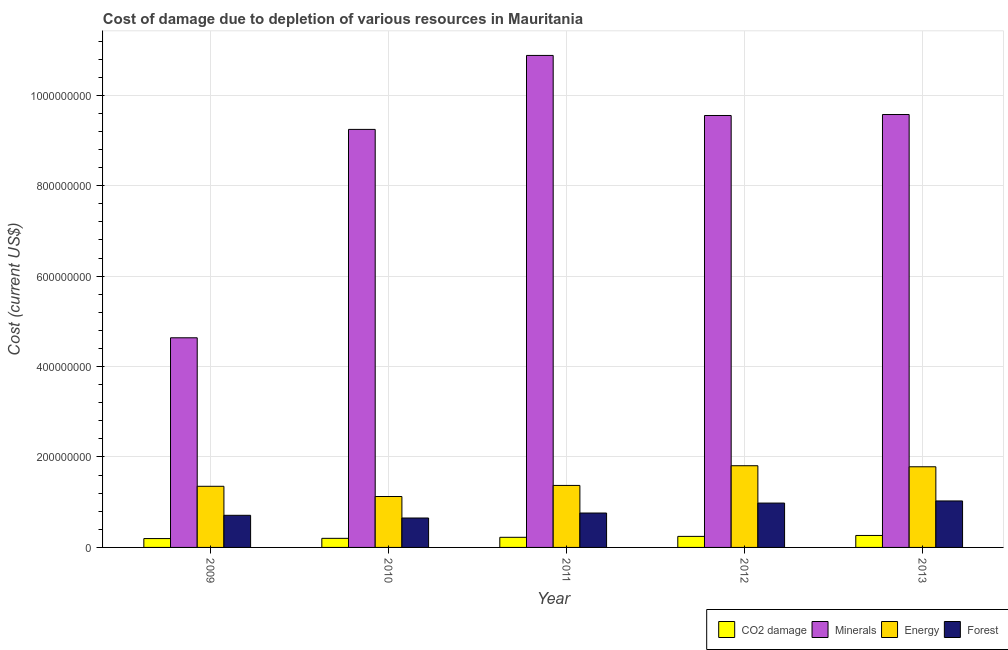How many different coloured bars are there?
Your answer should be compact. 4. How many groups of bars are there?
Your answer should be very brief. 5. Are the number of bars on each tick of the X-axis equal?
Your response must be concise. Yes. How many bars are there on the 3rd tick from the left?
Ensure brevity in your answer.  4. What is the label of the 2nd group of bars from the left?
Offer a terse response. 2010. What is the cost of damage due to depletion of minerals in 2013?
Ensure brevity in your answer.  9.57e+08. Across all years, what is the maximum cost of damage due to depletion of minerals?
Ensure brevity in your answer.  1.09e+09. Across all years, what is the minimum cost of damage due to depletion of minerals?
Provide a short and direct response. 4.64e+08. What is the total cost of damage due to depletion of forests in the graph?
Give a very brief answer. 4.13e+08. What is the difference between the cost of damage due to depletion of forests in 2010 and that in 2011?
Keep it short and to the point. -1.10e+07. What is the difference between the cost of damage due to depletion of forests in 2010 and the cost of damage due to depletion of coal in 2013?
Provide a short and direct response. -3.77e+07. What is the average cost of damage due to depletion of minerals per year?
Your answer should be very brief. 8.78e+08. In the year 2010, what is the difference between the cost of damage due to depletion of coal and cost of damage due to depletion of forests?
Your response must be concise. 0. What is the ratio of the cost of damage due to depletion of coal in 2010 to that in 2012?
Your answer should be compact. 0.82. Is the cost of damage due to depletion of energy in 2012 less than that in 2013?
Your answer should be very brief. No. Is the difference between the cost of damage due to depletion of forests in 2011 and 2012 greater than the difference between the cost of damage due to depletion of minerals in 2011 and 2012?
Make the answer very short. No. What is the difference between the highest and the second highest cost of damage due to depletion of forests?
Offer a terse response. 4.69e+06. What is the difference between the highest and the lowest cost of damage due to depletion of minerals?
Your answer should be compact. 6.24e+08. Is the sum of the cost of damage due to depletion of minerals in 2010 and 2012 greater than the maximum cost of damage due to depletion of coal across all years?
Your answer should be compact. Yes. What does the 3rd bar from the left in 2009 represents?
Your answer should be compact. Energy. What does the 1st bar from the right in 2013 represents?
Your response must be concise. Forest. Where does the legend appear in the graph?
Give a very brief answer. Bottom right. How many legend labels are there?
Make the answer very short. 4. How are the legend labels stacked?
Your answer should be very brief. Horizontal. What is the title of the graph?
Offer a terse response. Cost of damage due to depletion of various resources in Mauritania . What is the label or title of the X-axis?
Keep it short and to the point. Year. What is the label or title of the Y-axis?
Provide a short and direct response. Cost (current US$). What is the Cost (current US$) of CO2 damage in 2009?
Offer a very short reply. 1.96e+07. What is the Cost (current US$) of Minerals in 2009?
Give a very brief answer. 4.64e+08. What is the Cost (current US$) of Energy in 2009?
Your answer should be very brief. 1.35e+08. What is the Cost (current US$) in Forest in 2009?
Offer a very short reply. 7.10e+07. What is the Cost (current US$) of CO2 damage in 2010?
Provide a short and direct response. 2.01e+07. What is the Cost (current US$) in Minerals in 2010?
Give a very brief answer. 9.25e+08. What is the Cost (current US$) of Energy in 2010?
Provide a short and direct response. 1.13e+08. What is the Cost (current US$) of Forest in 2010?
Keep it short and to the point. 6.51e+07. What is the Cost (current US$) in CO2 damage in 2011?
Provide a succinct answer. 2.24e+07. What is the Cost (current US$) in Minerals in 2011?
Offer a terse response. 1.09e+09. What is the Cost (current US$) of Energy in 2011?
Give a very brief answer. 1.37e+08. What is the Cost (current US$) in Forest in 2011?
Your response must be concise. 7.61e+07. What is the Cost (current US$) in CO2 damage in 2012?
Provide a succinct answer. 2.44e+07. What is the Cost (current US$) of Minerals in 2012?
Offer a terse response. 9.55e+08. What is the Cost (current US$) in Energy in 2012?
Provide a succinct answer. 1.81e+08. What is the Cost (current US$) in Forest in 2012?
Your answer should be very brief. 9.81e+07. What is the Cost (current US$) in CO2 damage in 2013?
Keep it short and to the point. 2.65e+07. What is the Cost (current US$) of Minerals in 2013?
Offer a terse response. 9.57e+08. What is the Cost (current US$) in Energy in 2013?
Your answer should be compact. 1.78e+08. What is the Cost (current US$) in Forest in 2013?
Offer a terse response. 1.03e+08. Across all years, what is the maximum Cost (current US$) in CO2 damage?
Offer a very short reply. 2.65e+07. Across all years, what is the maximum Cost (current US$) of Minerals?
Provide a short and direct response. 1.09e+09. Across all years, what is the maximum Cost (current US$) in Energy?
Your answer should be compact. 1.81e+08. Across all years, what is the maximum Cost (current US$) of Forest?
Your answer should be compact. 1.03e+08. Across all years, what is the minimum Cost (current US$) of CO2 damage?
Ensure brevity in your answer.  1.96e+07. Across all years, what is the minimum Cost (current US$) of Minerals?
Make the answer very short. 4.64e+08. Across all years, what is the minimum Cost (current US$) in Energy?
Provide a succinct answer. 1.13e+08. Across all years, what is the minimum Cost (current US$) of Forest?
Provide a succinct answer. 6.51e+07. What is the total Cost (current US$) of CO2 damage in the graph?
Ensure brevity in your answer.  1.13e+08. What is the total Cost (current US$) of Minerals in the graph?
Give a very brief answer. 4.39e+09. What is the total Cost (current US$) in Energy in the graph?
Ensure brevity in your answer.  7.44e+08. What is the total Cost (current US$) of Forest in the graph?
Keep it short and to the point. 4.13e+08. What is the difference between the Cost (current US$) of CO2 damage in 2009 and that in 2010?
Your response must be concise. -5.16e+05. What is the difference between the Cost (current US$) of Minerals in 2009 and that in 2010?
Make the answer very short. -4.61e+08. What is the difference between the Cost (current US$) of Energy in 2009 and that in 2010?
Make the answer very short. 2.26e+07. What is the difference between the Cost (current US$) of Forest in 2009 and that in 2010?
Offer a terse response. 5.96e+06. What is the difference between the Cost (current US$) of CO2 damage in 2009 and that in 2011?
Offer a very short reply. -2.82e+06. What is the difference between the Cost (current US$) of Minerals in 2009 and that in 2011?
Give a very brief answer. -6.24e+08. What is the difference between the Cost (current US$) of Energy in 2009 and that in 2011?
Your response must be concise. -1.92e+06. What is the difference between the Cost (current US$) of Forest in 2009 and that in 2011?
Give a very brief answer. -5.06e+06. What is the difference between the Cost (current US$) in CO2 damage in 2009 and that in 2012?
Keep it short and to the point. -4.83e+06. What is the difference between the Cost (current US$) in Minerals in 2009 and that in 2012?
Keep it short and to the point. -4.92e+08. What is the difference between the Cost (current US$) of Energy in 2009 and that in 2012?
Make the answer very short. -4.55e+07. What is the difference between the Cost (current US$) in Forest in 2009 and that in 2012?
Ensure brevity in your answer.  -2.71e+07. What is the difference between the Cost (current US$) of CO2 damage in 2009 and that in 2013?
Provide a short and direct response. -6.88e+06. What is the difference between the Cost (current US$) in Minerals in 2009 and that in 2013?
Ensure brevity in your answer.  -4.94e+08. What is the difference between the Cost (current US$) in Energy in 2009 and that in 2013?
Offer a very short reply. -4.32e+07. What is the difference between the Cost (current US$) of Forest in 2009 and that in 2013?
Your answer should be compact. -3.18e+07. What is the difference between the Cost (current US$) in CO2 damage in 2010 and that in 2011?
Your response must be concise. -2.30e+06. What is the difference between the Cost (current US$) in Minerals in 2010 and that in 2011?
Your response must be concise. -1.64e+08. What is the difference between the Cost (current US$) of Energy in 2010 and that in 2011?
Your answer should be very brief. -2.45e+07. What is the difference between the Cost (current US$) in Forest in 2010 and that in 2011?
Give a very brief answer. -1.10e+07. What is the difference between the Cost (current US$) in CO2 damage in 2010 and that in 2012?
Give a very brief answer. -4.32e+06. What is the difference between the Cost (current US$) of Minerals in 2010 and that in 2012?
Make the answer very short. -3.08e+07. What is the difference between the Cost (current US$) in Energy in 2010 and that in 2012?
Your response must be concise. -6.81e+07. What is the difference between the Cost (current US$) of Forest in 2010 and that in 2012?
Your answer should be very brief. -3.30e+07. What is the difference between the Cost (current US$) of CO2 damage in 2010 and that in 2013?
Provide a short and direct response. -6.36e+06. What is the difference between the Cost (current US$) in Minerals in 2010 and that in 2013?
Offer a very short reply. -3.29e+07. What is the difference between the Cost (current US$) of Energy in 2010 and that in 2013?
Your answer should be compact. -6.57e+07. What is the difference between the Cost (current US$) of Forest in 2010 and that in 2013?
Give a very brief answer. -3.77e+07. What is the difference between the Cost (current US$) of CO2 damage in 2011 and that in 2012?
Ensure brevity in your answer.  -2.02e+06. What is the difference between the Cost (current US$) in Minerals in 2011 and that in 2012?
Your answer should be compact. 1.33e+08. What is the difference between the Cost (current US$) of Energy in 2011 and that in 2012?
Your answer should be very brief. -4.36e+07. What is the difference between the Cost (current US$) in Forest in 2011 and that in 2012?
Offer a very short reply. -2.20e+07. What is the difference between the Cost (current US$) in CO2 damage in 2011 and that in 2013?
Offer a terse response. -4.06e+06. What is the difference between the Cost (current US$) of Minerals in 2011 and that in 2013?
Keep it short and to the point. 1.31e+08. What is the difference between the Cost (current US$) in Energy in 2011 and that in 2013?
Ensure brevity in your answer.  -4.12e+07. What is the difference between the Cost (current US$) of Forest in 2011 and that in 2013?
Keep it short and to the point. -2.67e+07. What is the difference between the Cost (current US$) in CO2 damage in 2012 and that in 2013?
Offer a very short reply. -2.04e+06. What is the difference between the Cost (current US$) of Minerals in 2012 and that in 2013?
Make the answer very short. -2.13e+06. What is the difference between the Cost (current US$) of Energy in 2012 and that in 2013?
Your response must be concise. 2.34e+06. What is the difference between the Cost (current US$) of Forest in 2012 and that in 2013?
Make the answer very short. -4.69e+06. What is the difference between the Cost (current US$) of CO2 damage in 2009 and the Cost (current US$) of Minerals in 2010?
Give a very brief answer. -9.05e+08. What is the difference between the Cost (current US$) of CO2 damage in 2009 and the Cost (current US$) of Energy in 2010?
Your answer should be very brief. -9.31e+07. What is the difference between the Cost (current US$) of CO2 damage in 2009 and the Cost (current US$) of Forest in 2010?
Provide a succinct answer. -4.55e+07. What is the difference between the Cost (current US$) in Minerals in 2009 and the Cost (current US$) in Energy in 2010?
Provide a succinct answer. 3.51e+08. What is the difference between the Cost (current US$) in Minerals in 2009 and the Cost (current US$) in Forest in 2010?
Your answer should be compact. 3.99e+08. What is the difference between the Cost (current US$) of Energy in 2009 and the Cost (current US$) of Forest in 2010?
Keep it short and to the point. 7.01e+07. What is the difference between the Cost (current US$) of CO2 damage in 2009 and the Cost (current US$) of Minerals in 2011?
Your answer should be very brief. -1.07e+09. What is the difference between the Cost (current US$) of CO2 damage in 2009 and the Cost (current US$) of Energy in 2011?
Offer a terse response. -1.18e+08. What is the difference between the Cost (current US$) in CO2 damage in 2009 and the Cost (current US$) in Forest in 2011?
Make the answer very short. -5.65e+07. What is the difference between the Cost (current US$) of Minerals in 2009 and the Cost (current US$) of Energy in 2011?
Make the answer very short. 3.27e+08. What is the difference between the Cost (current US$) in Minerals in 2009 and the Cost (current US$) in Forest in 2011?
Ensure brevity in your answer.  3.88e+08. What is the difference between the Cost (current US$) of Energy in 2009 and the Cost (current US$) of Forest in 2011?
Your answer should be very brief. 5.91e+07. What is the difference between the Cost (current US$) in CO2 damage in 2009 and the Cost (current US$) in Minerals in 2012?
Ensure brevity in your answer.  -9.36e+08. What is the difference between the Cost (current US$) of CO2 damage in 2009 and the Cost (current US$) of Energy in 2012?
Your answer should be compact. -1.61e+08. What is the difference between the Cost (current US$) in CO2 damage in 2009 and the Cost (current US$) in Forest in 2012?
Give a very brief answer. -7.85e+07. What is the difference between the Cost (current US$) in Minerals in 2009 and the Cost (current US$) in Energy in 2012?
Provide a succinct answer. 2.83e+08. What is the difference between the Cost (current US$) of Minerals in 2009 and the Cost (current US$) of Forest in 2012?
Give a very brief answer. 3.66e+08. What is the difference between the Cost (current US$) of Energy in 2009 and the Cost (current US$) of Forest in 2012?
Provide a succinct answer. 3.71e+07. What is the difference between the Cost (current US$) of CO2 damage in 2009 and the Cost (current US$) of Minerals in 2013?
Offer a very short reply. -9.38e+08. What is the difference between the Cost (current US$) of CO2 damage in 2009 and the Cost (current US$) of Energy in 2013?
Ensure brevity in your answer.  -1.59e+08. What is the difference between the Cost (current US$) in CO2 damage in 2009 and the Cost (current US$) in Forest in 2013?
Your answer should be very brief. -8.32e+07. What is the difference between the Cost (current US$) in Minerals in 2009 and the Cost (current US$) in Energy in 2013?
Your answer should be compact. 2.85e+08. What is the difference between the Cost (current US$) of Minerals in 2009 and the Cost (current US$) of Forest in 2013?
Your answer should be very brief. 3.61e+08. What is the difference between the Cost (current US$) in Energy in 2009 and the Cost (current US$) in Forest in 2013?
Your answer should be very brief. 3.24e+07. What is the difference between the Cost (current US$) of CO2 damage in 2010 and the Cost (current US$) of Minerals in 2011?
Keep it short and to the point. -1.07e+09. What is the difference between the Cost (current US$) in CO2 damage in 2010 and the Cost (current US$) in Energy in 2011?
Give a very brief answer. -1.17e+08. What is the difference between the Cost (current US$) of CO2 damage in 2010 and the Cost (current US$) of Forest in 2011?
Give a very brief answer. -5.60e+07. What is the difference between the Cost (current US$) of Minerals in 2010 and the Cost (current US$) of Energy in 2011?
Ensure brevity in your answer.  7.87e+08. What is the difference between the Cost (current US$) in Minerals in 2010 and the Cost (current US$) in Forest in 2011?
Provide a short and direct response. 8.48e+08. What is the difference between the Cost (current US$) of Energy in 2010 and the Cost (current US$) of Forest in 2011?
Offer a very short reply. 3.65e+07. What is the difference between the Cost (current US$) of CO2 damage in 2010 and the Cost (current US$) of Minerals in 2012?
Your answer should be compact. -9.35e+08. What is the difference between the Cost (current US$) in CO2 damage in 2010 and the Cost (current US$) in Energy in 2012?
Provide a succinct answer. -1.61e+08. What is the difference between the Cost (current US$) of CO2 damage in 2010 and the Cost (current US$) of Forest in 2012?
Your answer should be compact. -7.80e+07. What is the difference between the Cost (current US$) in Minerals in 2010 and the Cost (current US$) in Energy in 2012?
Provide a short and direct response. 7.44e+08. What is the difference between the Cost (current US$) in Minerals in 2010 and the Cost (current US$) in Forest in 2012?
Your response must be concise. 8.26e+08. What is the difference between the Cost (current US$) in Energy in 2010 and the Cost (current US$) in Forest in 2012?
Provide a short and direct response. 1.45e+07. What is the difference between the Cost (current US$) of CO2 damage in 2010 and the Cost (current US$) of Minerals in 2013?
Give a very brief answer. -9.37e+08. What is the difference between the Cost (current US$) of CO2 damage in 2010 and the Cost (current US$) of Energy in 2013?
Ensure brevity in your answer.  -1.58e+08. What is the difference between the Cost (current US$) in CO2 damage in 2010 and the Cost (current US$) in Forest in 2013?
Your response must be concise. -8.27e+07. What is the difference between the Cost (current US$) of Minerals in 2010 and the Cost (current US$) of Energy in 2013?
Your answer should be very brief. 7.46e+08. What is the difference between the Cost (current US$) of Minerals in 2010 and the Cost (current US$) of Forest in 2013?
Your answer should be compact. 8.22e+08. What is the difference between the Cost (current US$) in Energy in 2010 and the Cost (current US$) in Forest in 2013?
Your answer should be very brief. 9.83e+06. What is the difference between the Cost (current US$) in CO2 damage in 2011 and the Cost (current US$) in Minerals in 2012?
Ensure brevity in your answer.  -9.33e+08. What is the difference between the Cost (current US$) in CO2 damage in 2011 and the Cost (current US$) in Energy in 2012?
Keep it short and to the point. -1.58e+08. What is the difference between the Cost (current US$) in CO2 damage in 2011 and the Cost (current US$) in Forest in 2012?
Your answer should be compact. -7.57e+07. What is the difference between the Cost (current US$) of Minerals in 2011 and the Cost (current US$) of Energy in 2012?
Provide a succinct answer. 9.07e+08. What is the difference between the Cost (current US$) of Minerals in 2011 and the Cost (current US$) of Forest in 2012?
Ensure brevity in your answer.  9.90e+08. What is the difference between the Cost (current US$) in Energy in 2011 and the Cost (current US$) in Forest in 2012?
Make the answer very short. 3.90e+07. What is the difference between the Cost (current US$) of CO2 damage in 2011 and the Cost (current US$) of Minerals in 2013?
Provide a succinct answer. -9.35e+08. What is the difference between the Cost (current US$) in CO2 damage in 2011 and the Cost (current US$) in Energy in 2013?
Offer a terse response. -1.56e+08. What is the difference between the Cost (current US$) of CO2 damage in 2011 and the Cost (current US$) of Forest in 2013?
Your answer should be compact. -8.04e+07. What is the difference between the Cost (current US$) of Minerals in 2011 and the Cost (current US$) of Energy in 2013?
Provide a short and direct response. 9.10e+08. What is the difference between the Cost (current US$) of Minerals in 2011 and the Cost (current US$) of Forest in 2013?
Provide a succinct answer. 9.85e+08. What is the difference between the Cost (current US$) of Energy in 2011 and the Cost (current US$) of Forest in 2013?
Your response must be concise. 3.43e+07. What is the difference between the Cost (current US$) of CO2 damage in 2012 and the Cost (current US$) of Minerals in 2013?
Your answer should be compact. -9.33e+08. What is the difference between the Cost (current US$) of CO2 damage in 2012 and the Cost (current US$) of Energy in 2013?
Your answer should be very brief. -1.54e+08. What is the difference between the Cost (current US$) in CO2 damage in 2012 and the Cost (current US$) in Forest in 2013?
Keep it short and to the point. -7.84e+07. What is the difference between the Cost (current US$) of Minerals in 2012 and the Cost (current US$) of Energy in 2013?
Your answer should be compact. 7.77e+08. What is the difference between the Cost (current US$) of Minerals in 2012 and the Cost (current US$) of Forest in 2013?
Offer a terse response. 8.53e+08. What is the difference between the Cost (current US$) in Energy in 2012 and the Cost (current US$) in Forest in 2013?
Provide a succinct answer. 7.79e+07. What is the average Cost (current US$) in CO2 damage per year?
Your answer should be compact. 2.26e+07. What is the average Cost (current US$) of Minerals per year?
Ensure brevity in your answer.  8.78e+08. What is the average Cost (current US$) in Energy per year?
Your response must be concise. 1.49e+08. What is the average Cost (current US$) in Forest per year?
Make the answer very short. 8.26e+07. In the year 2009, what is the difference between the Cost (current US$) in CO2 damage and Cost (current US$) in Minerals?
Keep it short and to the point. -4.44e+08. In the year 2009, what is the difference between the Cost (current US$) in CO2 damage and Cost (current US$) in Energy?
Keep it short and to the point. -1.16e+08. In the year 2009, what is the difference between the Cost (current US$) in CO2 damage and Cost (current US$) in Forest?
Provide a short and direct response. -5.15e+07. In the year 2009, what is the difference between the Cost (current US$) of Minerals and Cost (current US$) of Energy?
Your response must be concise. 3.28e+08. In the year 2009, what is the difference between the Cost (current US$) of Minerals and Cost (current US$) of Forest?
Keep it short and to the point. 3.93e+08. In the year 2009, what is the difference between the Cost (current US$) in Energy and Cost (current US$) in Forest?
Your answer should be compact. 6.42e+07. In the year 2010, what is the difference between the Cost (current US$) of CO2 damage and Cost (current US$) of Minerals?
Ensure brevity in your answer.  -9.04e+08. In the year 2010, what is the difference between the Cost (current US$) in CO2 damage and Cost (current US$) in Energy?
Provide a short and direct response. -9.25e+07. In the year 2010, what is the difference between the Cost (current US$) in CO2 damage and Cost (current US$) in Forest?
Offer a terse response. -4.50e+07. In the year 2010, what is the difference between the Cost (current US$) in Minerals and Cost (current US$) in Energy?
Your response must be concise. 8.12e+08. In the year 2010, what is the difference between the Cost (current US$) of Minerals and Cost (current US$) of Forest?
Provide a succinct answer. 8.59e+08. In the year 2010, what is the difference between the Cost (current US$) of Energy and Cost (current US$) of Forest?
Your response must be concise. 4.76e+07. In the year 2011, what is the difference between the Cost (current US$) of CO2 damage and Cost (current US$) of Minerals?
Give a very brief answer. -1.07e+09. In the year 2011, what is the difference between the Cost (current US$) in CO2 damage and Cost (current US$) in Energy?
Your response must be concise. -1.15e+08. In the year 2011, what is the difference between the Cost (current US$) of CO2 damage and Cost (current US$) of Forest?
Make the answer very short. -5.37e+07. In the year 2011, what is the difference between the Cost (current US$) of Minerals and Cost (current US$) of Energy?
Your answer should be very brief. 9.51e+08. In the year 2011, what is the difference between the Cost (current US$) in Minerals and Cost (current US$) in Forest?
Your answer should be very brief. 1.01e+09. In the year 2011, what is the difference between the Cost (current US$) in Energy and Cost (current US$) in Forest?
Your response must be concise. 6.10e+07. In the year 2012, what is the difference between the Cost (current US$) of CO2 damage and Cost (current US$) of Minerals?
Your answer should be compact. -9.31e+08. In the year 2012, what is the difference between the Cost (current US$) of CO2 damage and Cost (current US$) of Energy?
Provide a succinct answer. -1.56e+08. In the year 2012, what is the difference between the Cost (current US$) in CO2 damage and Cost (current US$) in Forest?
Provide a short and direct response. -7.37e+07. In the year 2012, what is the difference between the Cost (current US$) in Minerals and Cost (current US$) in Energy?
Keep it short and to the point. 7.75e+08. In the year 2012, what is the difference between the Cost (current US$) of Minerals and Cost (current US$) of Forest?
Your response must be concise. 8.57e+08. In the year 2012, what is the difference between the Cost (current US$) of Energy and Cost (current US$) of Forest?
Keep it short and to the point. 8.26e+07. In the year 2013, what is the difference between the Cost (current US$) of CO2 damage and Cost (current US$) of Minerals?
Your answer should be very brief. -9.31e+08. In the year 2013, what is the difference between the Cost (current US$) in CO2 damage and Cost (current US$) in Energy?
Your response must be concise. -1.52e+08. In the year 2013, what is the difference between the Cost (current US$) of CO2 damage and Cost (current US$) of Forest?
Your answer should be compact. -7.63e+07. In the year 2013, what is the difference between the Cost (current US$) of Minerals and Cost (current US$) of Energy?
Provide a short and direct response. 7.79e+08. In the year 2013, what is the difference between the Cost (current US$) of Minerals and Cost (current US$) of Forest?
Your response must be concise. 8.55e+08. In the year 2013, what is the difference between the Cost (current US$) of Energy and Cost (current US$) of Forest?
Your response must be concise. 7.56e+07. What is the ratio of the Cost (current US$) of CO2 damage in 2009 to that in 2010?
Give a very brief answer. 0.97. What is the ratio of the Cost (current US$) in Minerals in 2009 to that in 2010?
Give a very brief answer. 0.5. What is the ratio of the Cost (current US$) of Energy in 2009 to that in 2010?
Offer a very short reply. 1.2. What is the ratio of the Cost (current US$) in Forest in 2009 to that in 2010?
Give a very brief answer. 1.09. What is the ratio of the Cost (current US$) in CO2 damage in 2009 to that in 2011?
Make the answer very short. 0.87. What is the ratio of the Cost (current US$) of Minerals in 2009 to that in 2011?
Keep it short and to the point. 0.43. What is the ratio of the Cost (current US$) of Forest in 2009 to that in 2011?
Offer a terse response. 0.93. What is the ratio of the Cost (current US$) of CO2 damage in 2009 to that in 2012?
Provide a succinct answer. 0.8. What is the ratio of the Cost (current US$) in Minerals in 2009 to that in 2012?
Offer a very short reply. 0.49. What is the ratio of the Cost (current US$) in Energy in 2009 to that in 2012?
Your response must be concise. 0.75. What is the ratio of the Cost (current US$) of Forest in 2009 to that in 2012?
Your response must be concise. 0.72. What is the ratio of the Cost (current US$) in CO2 damage in 2009 to that in 2013?
Make the answer very short. 0.74. What is the ratio of the Cost (current US$) of Minerals in 2009 to that in 2013?
Give a very brief answer. 0.48. What is the ratio of the Cost (current US$) in Energy in 2009 to that in 2013?
Make the answer very short. 0.76. What is the ratio of the Cost (current US$) in Forest in 2009 to that in 2013?
Give a very brief answer. 0.69. What is the ratio of the Cost (current US$) of CO2 damage in 2010 to that in 2011?
Offer a very short reply. 0.9. What is the ratio of the Cost (current US$) in Minerals in 2010 to that in 2011?
Provide a short and direct response. 0.85. What is the ratio of the Cost (current US$) in Energy in 2010 to that in 2011?
Make the answer very short. 0.82. What is the ratio of the Cost (current US$) of Forest in 2010 to that in 2011?
Give a very brief answer. 0.86. What is the ratio of the Cost (current US$) of CO2 damage in 2010 to that in 2012?
Ensure brevity in your answer.  0.82. What is the ratio of the Cost (current US$) in Minerals in 2010 to that in 2012?
Your answer should be very brief. 0.97. What is the ratio of the Cost (current US$) of Energy in 2010 to that in 2012?
Keep it short and to the point. 0.62. What is the ratio of the Cost (current US$) in Forest in 2010 to that in 2012?
Ensure brevity in your answer.  0.66. What is the ratio of the Cost (current US$) in CO2 damage in 2010 to that in 2013?
Keep it short and to the point. 0.76. What is the ratio of the Cost (current US$) in Minerals in 2010 to that in 2013?
Provide a short and direct response. 0.97. What is the ratio of the Cost (current US$) in Energy in 2010 to that in 2013?
Offer a terse response. 0.63. What is the ratio of the Cost (current US$) of Forest in 2010 to that in 2013?
Offer a terse response. 0.63. What is the ratio of the Cost (current US$) in CO2 damage in 2011 to that in 2012?
Ensure brevity in your answer.  0.92. What is the ratio of the Cost (current US$) of Minerals in 2011 to that in 2012?
Your response must be concise. 1.14. What is the ratio of the Cost (current US$) of Energy in 2011 to that in 2012?
Your response must be concise. 0.76. What is the ratio of the Cost (current US$) of Forest in 2011 to that in 2012?
Offer a very short reply. 0.78. What is the ratio of the Cost (current US$) in CO2 damage in 2011 to that in 2013?
Make the answer very short. 0.85. What is the ratio of the Cost (current US$) in Minerals in 2011 to that in 2013?
Your response must be concise. 1.14. What is the ratio of the Cost (current US$) in Energy in 2011 to that in 2013?
Ensure brevity in your answer.  0.77. What is the ratio of the Cost (current US$) in Forest in 2011 to that in 2013?
Provide a short and direct response. 0.74. What is the ratio of the Cost (current US$) in CO2 damage in 2012 to that in 2013?
Offer a very short reply. 0.92. What is the ratio of the Cost (current US$) of Minerals in 2012 to that in 2013?
Ensure brevity in your answer.  1. What is the ratio of the Cost (current US$) in Energy in 2012 to that in 2013?
Ensure brevity in your answer.  1.01. What is the ratio of the Cost (current US$) in Forest in 2012 to that in 2013?
Offer a very short reply. 0.95. What is the difference between the highest and the second highest Cost (current US$) in CO2 damage?
Offer a terse response. 2.04e+06. What is the difference between the highest and the second highest Cost (current US$) in Minerals?
Your answer should be very brief. 1.31e+08. What is the difference between the highest and the second highest Cost (current US$) of Energy?
Your response must be concise. 2.34e+06. What is the difference between the highest and the second highest Cost (current US$) of Forest?
Offer a very short reply. 4.69e+06. What is the difference between the highest and the lowest Cost (current US$) in CO2 damage?
Your answer should be very brief. 6.88e+06. What is the difference between the highest and the lowest Cost (current US$) of Minerals?
Offer a terse response. 6.24e+08. What is the difference between the highest and the lowest Cost (current US$) in Energy?
Your answer should be compact. 6.81e+07. What is the difference between the highest and the lowest Cost (current US$) of Forest?
Provide a short and direct response. 3.77e+07. 